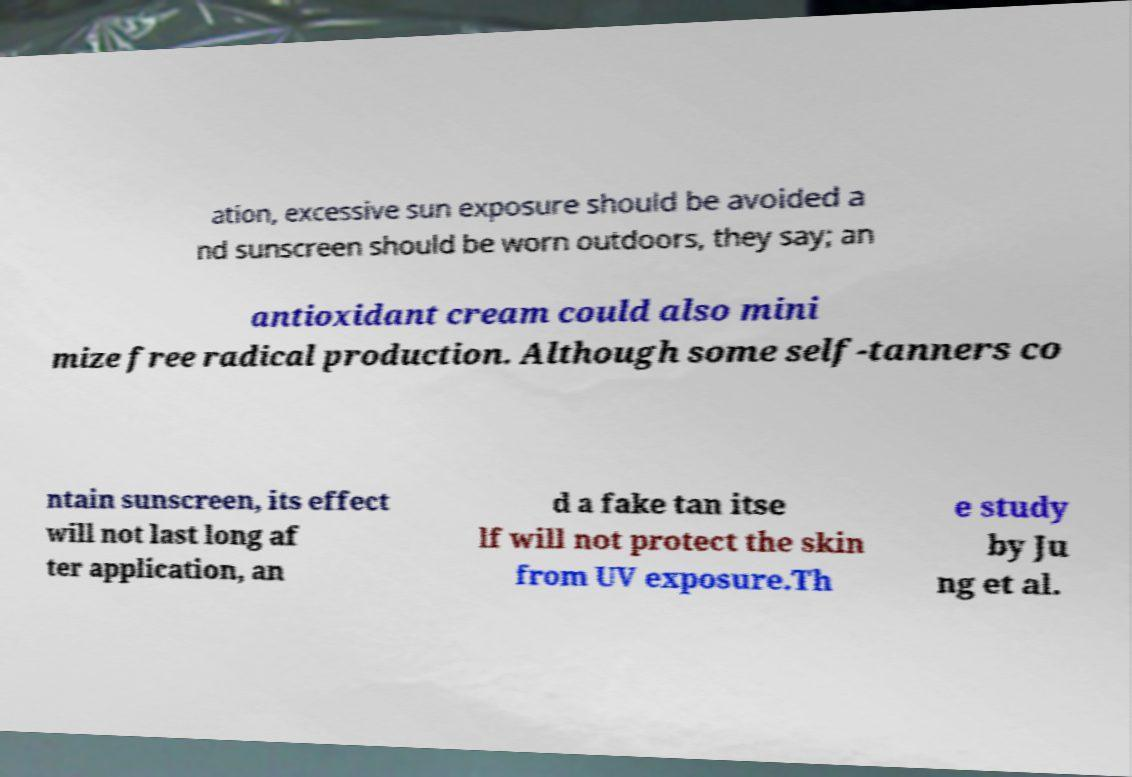Please identify and transcribe the text found in this image. ation, excessive sun exposure should be avoided a nd sunscreen should be worn outdoors, they say; an antioxidant cream could also mini mize free radical production. Although some self-tanners co ntain sunscreen, its effect will not last long af ter application, an d a fake tan itse lf will not protect the skin from UV exposure.Th e study by Ju ng et al. 